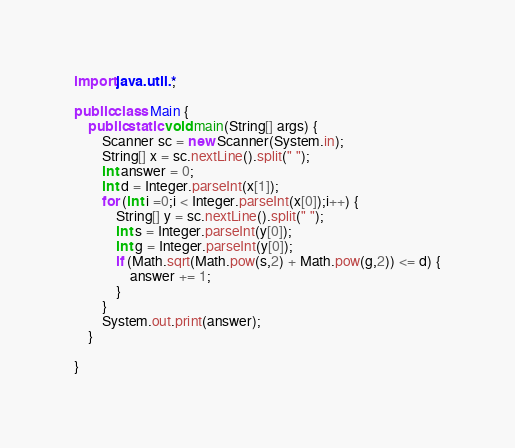Convert code to text. <code><loc_0><loc_0><loc_500><loc_500><_Java_>import java.util.*;

public class Main {
	public static void main(String[] args) {
	    Scanner sc = new Scanner(System.in);
		String[] x = sc.nextLine().split(" ");
		int answer = 0;
		int d = Integer.parseInt(x[1]);
		for (int i =0;i < Integer.parseInt(x[0]);i++) {
			String[] y = sc.nextLine().split(" ");
			int s = Integer.parseInt(y[0]);
			int g = Integer.parseInt(y[0]);
			if (Math.sqrt(Math.pow(s,2) + Math.pow(g,2)) <= d) {
				answer += 1;
			}
		}
		System.out.print(answer);
	}

}</code> 